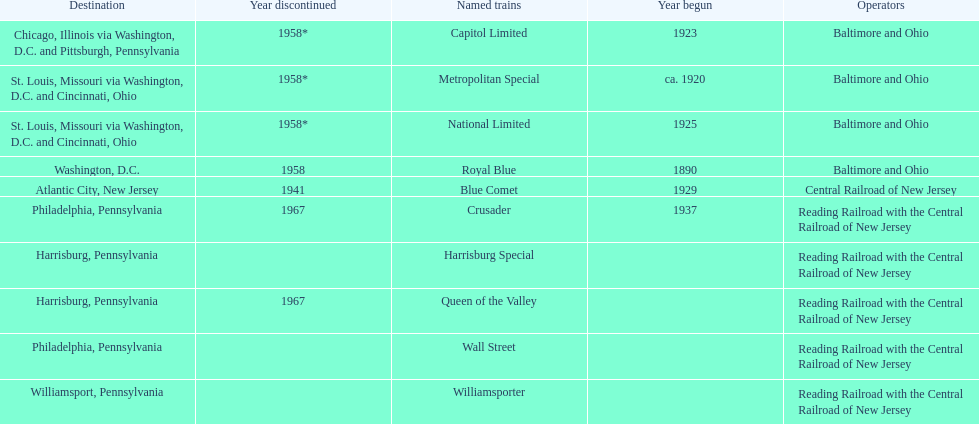Which other traine, other than wall street, had philadelphia as a destination? Crusader. 